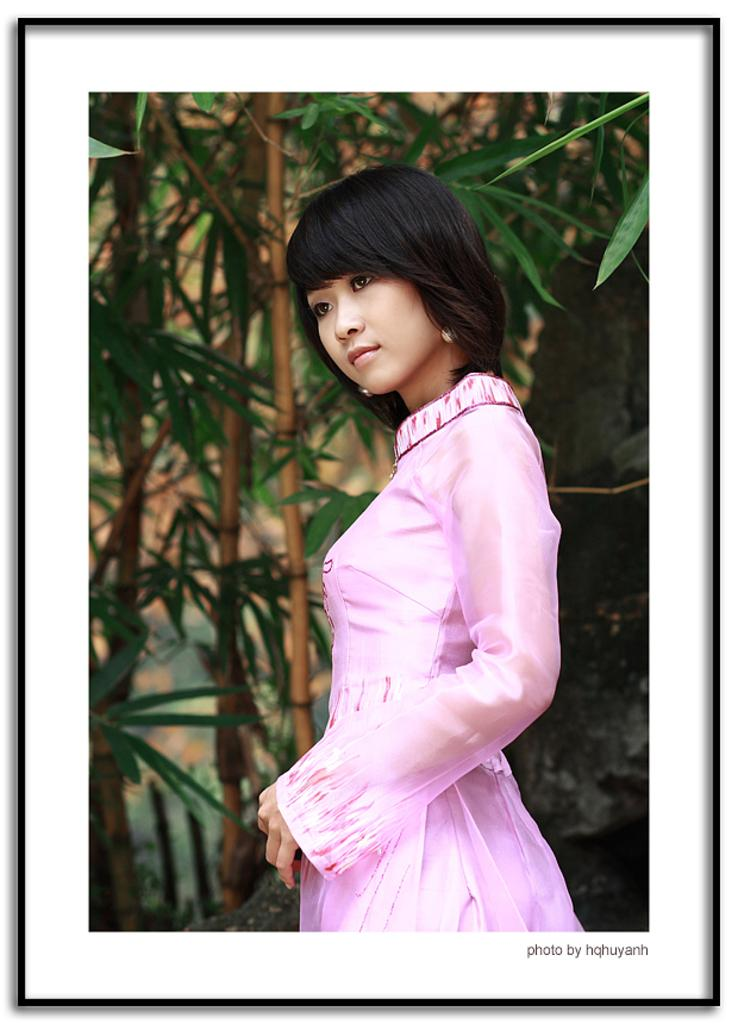What is the main subject in the image? There is a lady standing in the image. What can be seen in the background of the image? There are trees in the background of the image. Is there any text present in the image? Yes, there is text in the bottom right corner of the image. What type of shoes is the lady's father wearing in the image? There is no mention of the lady's father or any shoes in the image. 